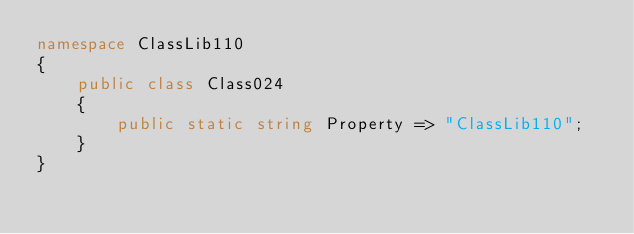Convert code to text. <code><loc_0><loc_0><loc_500><loc_500><_C#_>namespace ClassLib110
{
    public class Class024
    {
        public static string Property => "ClassLib110";
    }
}
</code> 